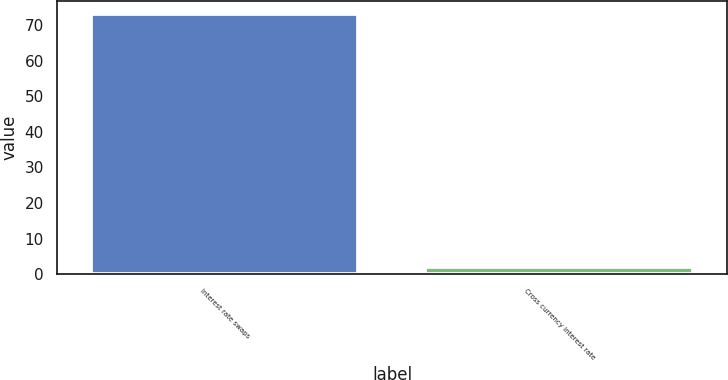Convert chart to OTSL. <chart><loc_0><loc_0><loc_500><loc_500><bar_chart><fcel>Interest rate swaps<fcel>Cross currency interest rate<nl><fcel>73<fcel>2<nl></chart> 